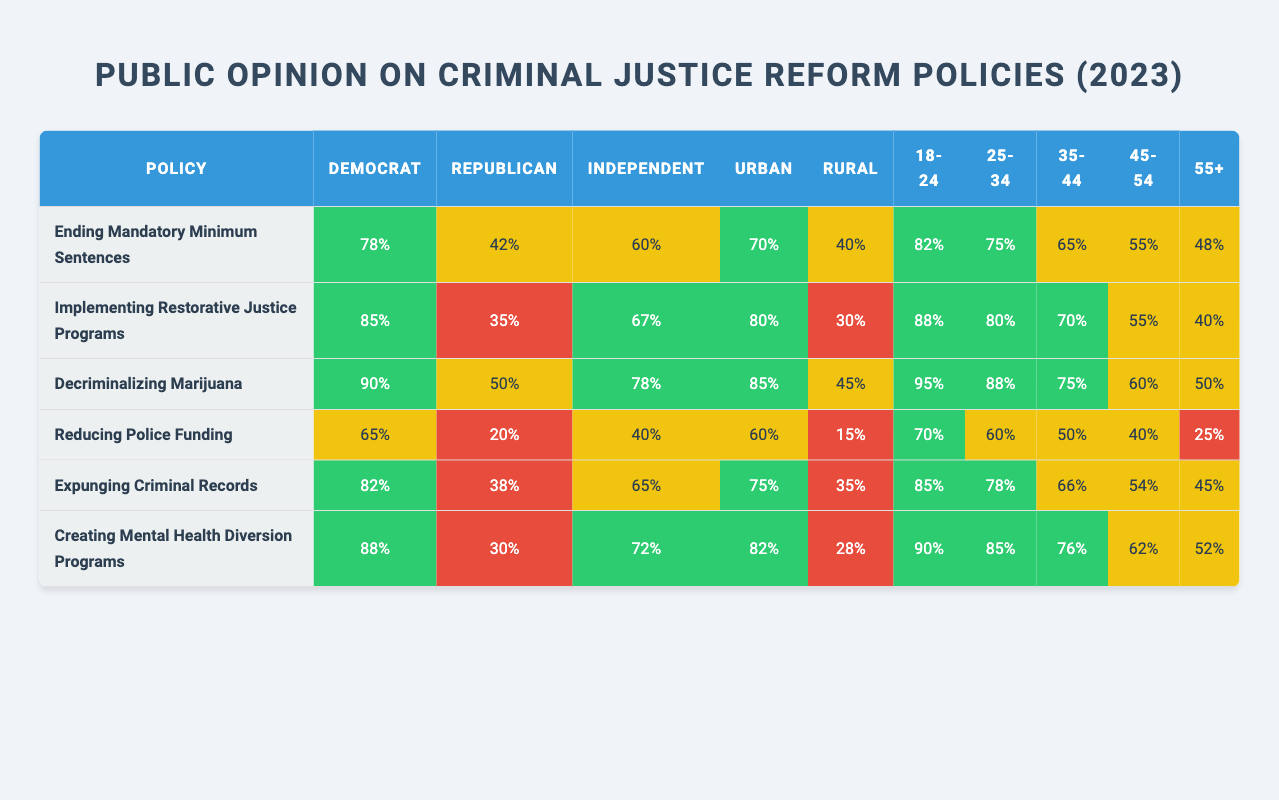What percentage of Democrats support decriminalizing marijuana? Looking at the row for "Decriminalizing Marijuana" under the "Democrat" column, the percentage is 90%.
Answer: 90% What is the lowest support percentage for any policy among Republicans? The lowest support percentage in the Republican column is 20% for the policy of "Reducing Police Funding."
Answer: 20% Which age group has the highest support for creating mental health diversion programs? The age group 18-24 has the highest percentage of support at 90%, which is listed under the "Creating Mental Health Diversion Programs" row.
Answer: 90% What’s the difference in support for implementing restorative justice programs between Democrats and Independents? Democrats support this policy at 85% while Independents support it at 67%. The difference is calculated as 85% - 67% = 18%.
Answer: 18% Is the support for reducing police funding higher among urban residents than rural residents? In the "Reducing Police Funding" row, urban support is at 60% and rural support is at 15%. Thus, urban support is indeed higher.
Answer: Yes What is the average support percentage for the "Expunging Criminal Records" policy across all age groups? To find the average: (85 + 78 + 66 + 54 + 45) / 5 = 65.6%. Thus, rounding gives an average support of approximately 66%.
Answer: 66% In which demographic does support for ending mandatory minimum sentences differ the most? Support for Democrats is 78% versus Rural being 40%, giving a difference of 38%. This is the largest difference among demographics for this policy.
Answer: 38% What policies have over 80% support from Independents? The policies with over 80% support from Independents are "Decriminalizing Marijuana" (78%), "Ending Mandatory Minimum Sentences" (60%), and "Implementing Restorative Justice Programs" (67%). Therefore, only "Decriminalizing Marijuana" meets this threshold.
Answer: 1 policy What percentage of rural voters support creating mental health diversion programs? In the row for "Creating Mental Health Diversion Programs," the support from rural voters is 28%.
Answer: 28% Which group has the least support overall for implementing restorative justice programs? The Republican group has the least support at 35% in the "Implementing Restorative Justice Programs" row.
Answer: 35% 